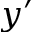<formula> <loc_0><loc_0><loc_500><loc_500>y ^ { \prime }</formula> 